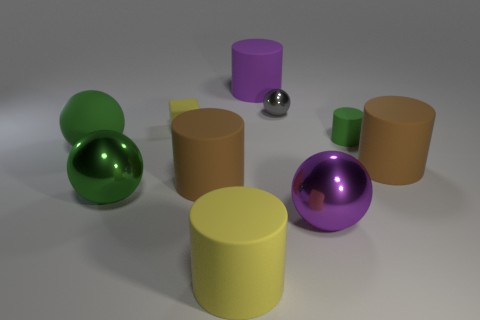Subtract 1 spheres. How many spheres are left? 3 Subtract all yellow cylinders. How many cylinders are left? 4 Subtract all green cylinders. How many cylinders are left? 4 Subtract all gray cylinders. Subtract all cyan balls. How many cylinders are left? 5 Subtract all spheres. How many objects are left? 6 Subtract all large yellow objects. Subtract all big brown matte cubes. How many objects are left? 9 Add 2 purple objects. How many purple objects are left? 4 Add 3 tiny cyan matte spheres. How many tiny cyan matte spheres exist? 3 Subtract 1 green cylinders. How many objects are left? 9 